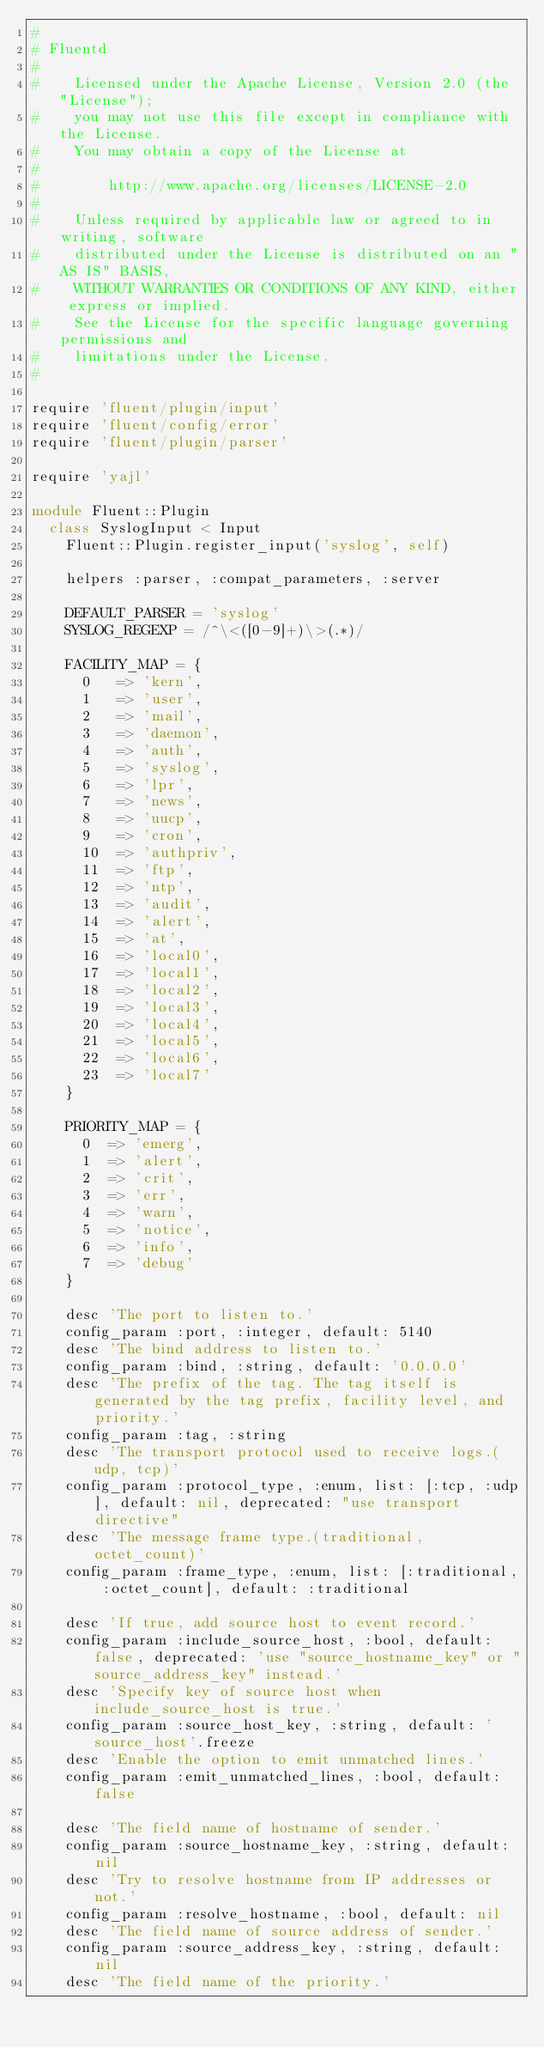<code> <loc_0><loc_0><loc_500><loc_500><_Ruby_>#
# Fluentd
#
#    Licensed under the Apache License, Version 2.0 (the "License");
#    you may not use this file except in compliance with the License.
#    You may obtain a copy of the License at
#
#        http://www.apache.org/licenses/LICENSE-2.0
#
#    Unless required by applicable law or agreed to in writing, software
#    distributed under the License is distributed on an "AS IS" BASIS,
#    WITHOUT WARRANTIES OR CONDITIONS OF ANY KIND, either express or implied.
#    See the License for the specific language governing permissions and
#    limitations under the License.
#

require 'fluent/plugin/input'
require 'fluent/config/error'
require 'fluent/plugin/parser'

require 'yajl'

module Fluent::Plugin
  class SyslogInput < Input
    Fluent::Plugin.register_input('syslog', self)

    helpers :parser, :compat_parameters, :server

    DEFAULT_PARSER = 'syslog'
    SYSLOG_REGEXP = /^\<([0-9]+)\>(.*)/

    FACILITY_MAP = {
      0   => 'kern',
      1   => 'user',
      2   => 'mail',
      3   => 'daemon',
      4   => 'auth',
      5   => 'syslog',
      6   => 'lpr',
      7   => 'news',
      8   => 'uucp',
      9   => 'cron',
      10  => 'authpriv',
      11  => 'ftp',
      12  => 'ntp',
      13  => 'audit',
      14  => 'alert',
      15  => 'at',
      16  => 'local0',
      17  => 'local1',
      18  => 'local2',
      19  => 'local3',
      20  => 'local4',
      21  => 'local5',
      22  => 'local6',
      23  => 'local7'
    }

    PRIORITY_MAP = {
      0  => 'emerg',
      1  => 'alert',
      2  => 'crit',
      3  => 'err',
      4  => 'warn',
      5  => 'notice',
      6  => 'info',
      7  => 'debug'
    }

    desc 'The port to listen to.'
    config_param :port, :integer, default: 5140
    desc 'The bind address to listen to.'
    config_param :bind, :string, default: '0.0.0.0'
    desc 'The prefix of the tag. The tag itself is generated by the tag prefix, facility level, and priority.'
    config_param :tag, :string
    desc 'The transport protocol used to receive logs.(udp, tcp)'
    config_param :protocol_type, :enum, list: [:tcp, :udp], default: nil, deprecated: "use transport directive"
    desc 'The message frame type.(traditional, octet_count)'
    config_param :frame_type, :enum, list: [:traditional, :octet_count], default: :traditional

    desc 'If true, add source host to event record.'
    config_param :include_source_host, :bool, default: false, deprecated: 'use "source_hostname_key" or "source_address_key" instead.'
    desc 'Specify key of source host when include_source_host is true.'
    config_param :source_host_key, :string, default: 'source_host'.freeze
    desc 'Enable the option to emit unmatched lines.'
    config_param :emit_unmatched_lines, :bool, default: false

    desc 'The field name of hostname of sender.'
    config_param :source_hostname_key, :string, default: nil
    desc 'Try to resolve hostname from IP addresses or not.'
    config_param :resolve_hostname, :bool, default: nil
    desc 'The field name of source address of sender.'
    config_param :source_address_key, :string, default: nil
    desc 'The field name of the priority.'</code> 